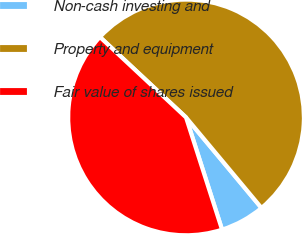<chart> <loc_0><loc_0><loc_500><loc_500><pie_chart><fcel>Non-cash investing and<fcel>Property and equipment<fcel>Fair value of shares issued<nl><fcel>6.12%<fcel>51.99%<fcel>41.9%<nl></chart> 